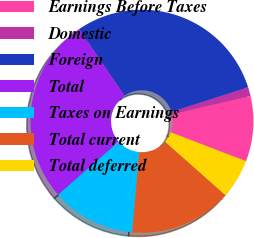Convert chart to OTSL. <chart><loc_0><loc_0><loc_500><loc_500><pie_chart><fcel>Earnings Before Taxes<fcel>Domestic<fcel>Foreign<fcel>Total<fcel>Taxes on Earnings<fcel>Total current<fcel>Total deferred<nl><fcel>9.47%<fcel>1.3%<fcel>29.61%<fcel>26.91%<fcel>12.16%<fcel>14.85%<fcel>5.7%<nl></chart> 